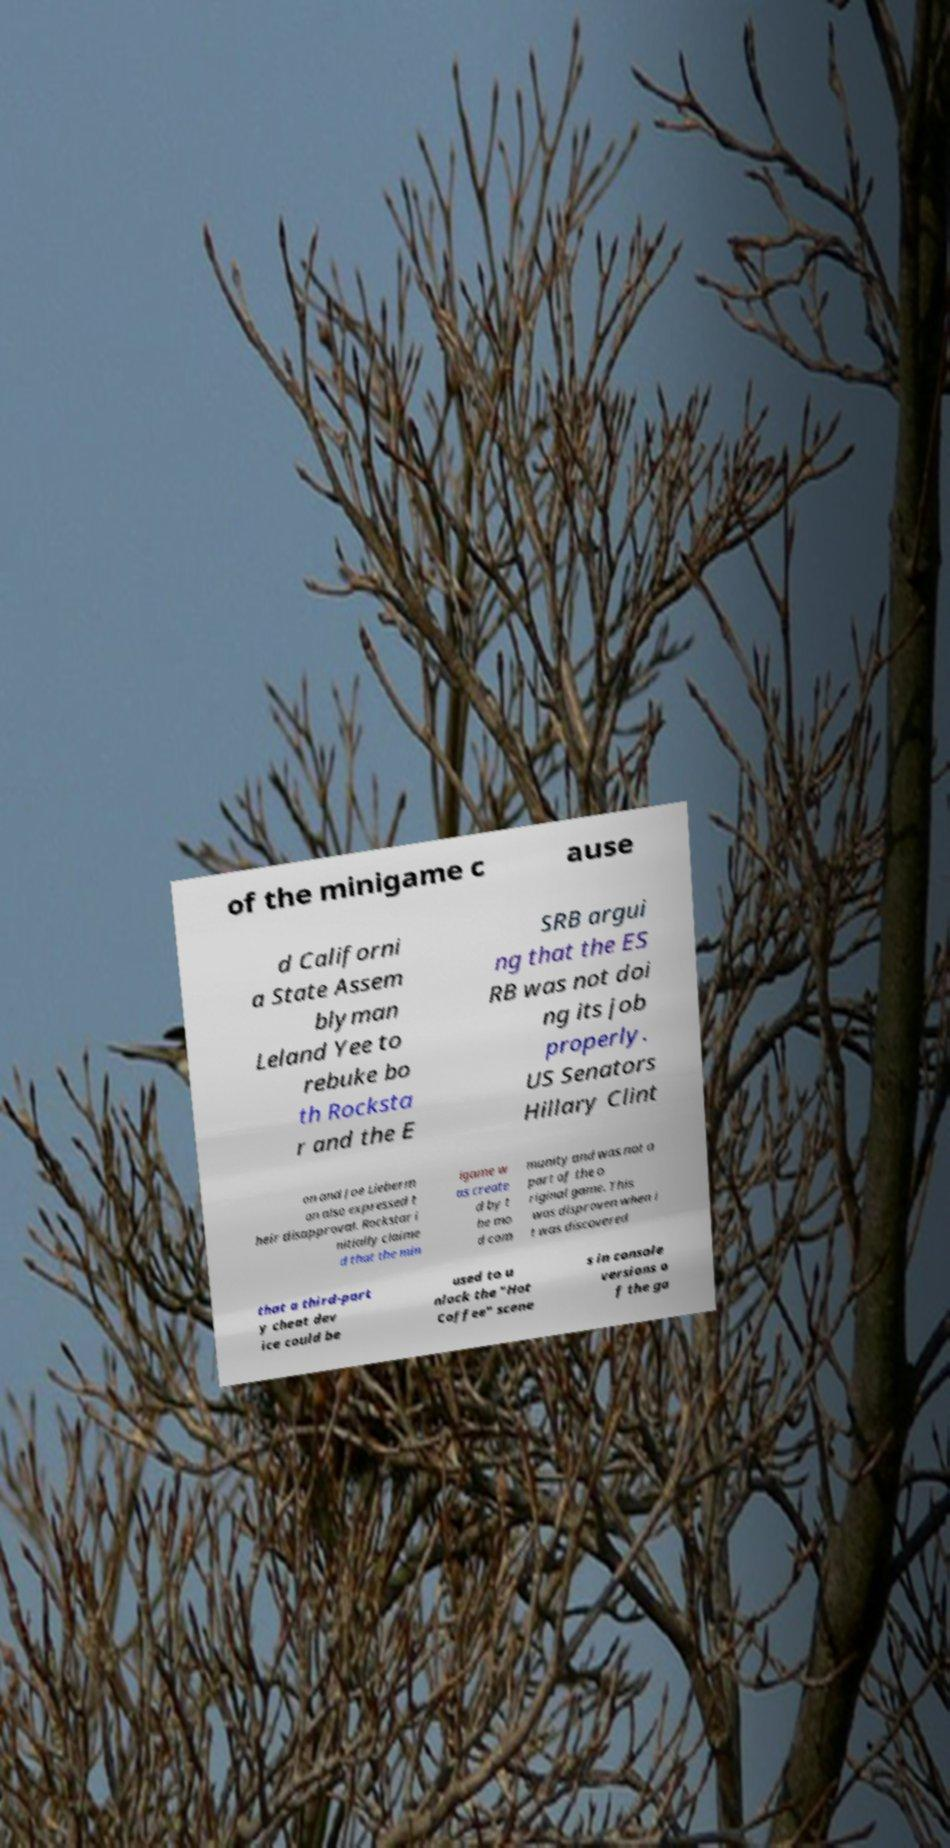Can you read and provide the text displayed in the image?This photo seems to have some interesting text. Can you extract and type it out for me? of the minigame c ause d Californi a State Assem blyman Leland Yee to rebuke bo th Rocksta r and the E SRB argui ng that the ES RB was not doi ng its job properly. US Senators Hillary Clint on and Joe Lieberm an also expressed t heir disapproval. Rockstar i nitially claime d that the min igame w as create d by t he mo d com munity and was not a part of the o riginal game. This was disproven when i t was discovered that a third-part y cheat dev ice could be used to u nlock the "Hot Coffee" scene s in console versions o f the ga 